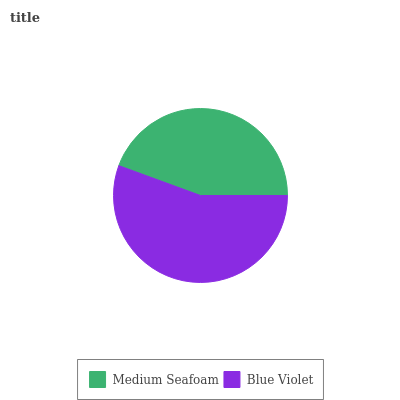Is Medium Seafoam the minimum?
Answer yes or no. Yes. Is Blue Violet the maximum?
Answer yes or no. Yes. Is Blue Violet the minimum?
Answer yes or no. No. Is Blue Violet greater than Medium Seafoam?
Answer yes or no. Yes. Is Medium Seafoam less than Blue Violet?
Answer yes or no. Yes. Is Medium Seafoam greater than Blue Violet?
Answer yes or no. No. Is Blue Violet less than Medium Seafoam?
Answer yes or no. No. Is Blue Violet the high median?
Answer yes or no. Yes. Is Medium Seafoam the low median?
Answer yes or no. Yes. Is Medium Seafoam the high median?
Answer yes or no. No. Is Blue Violet the low median?
Answer yes or no. No. 